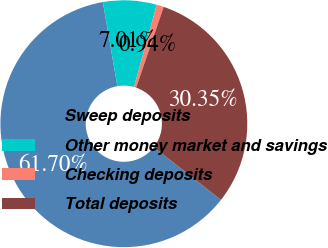Convert chart to OTSL. <chart><loc_0><loc_0><loc_500><loc_500><pie_chart><fcel>Sweep deposits<fcel>Other money market and savings<fcel>Checking deposits<fcel>Total deposits<nl><fcel>61.7%<fcel>7.01%<fcel>0.94%<fcel>30.35%<nl></chart> 